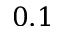Convert formula to latex. <formula><loc_0><loc_0><loc_500><loc_500>0 . 1</formula> 